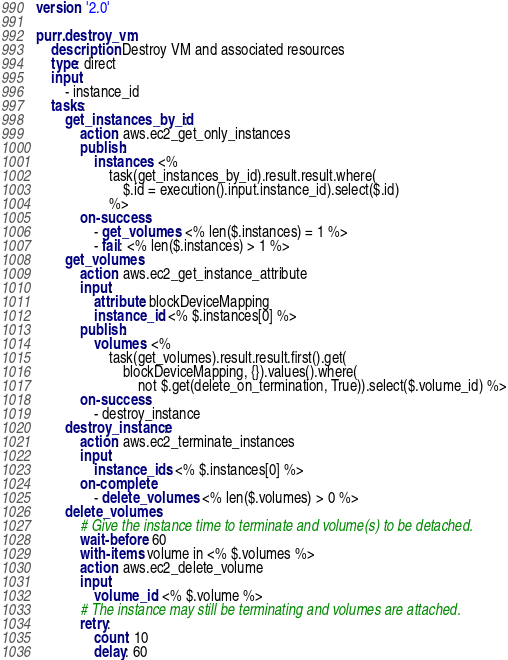Convert code to text. <code><loc_0><loc_0><loc_500><loc_500><_YAML_>version: '2.0'

purr.destroy_vm:
    description: Destroy VM and associated resources
    type: direct
    input:
        - instance_id
    tasks:
        get_instances_by_id:
            action: aws.ec2_get_only_instances
            publish:
                instances: <%
                    task(get_instances_by_id).result.result.where(
                        $.id = execution().input.instance_id).select($.id)
                    %>
            on-success:
                - get_volumes: <% len($.instances) = 1 %>
                - fail: <% len($.instances) > 1 %>
        get_volumes:
            action: aws.ec2_get_instance_attribute
            input:
                attribute: blockDeviceMapping
                instance_id: <% $.instances[0] %>
            publish:
                volumes: <%
                    task(get_volumes).result.result.first().get(
                        blockDeviceMapping, {}).values().where(
                            not $.get(delete_on_termination, True)).select($.volume_id) %>
            on-success:
                - destroy_instance
        destroy_instance:
            action: aws.ec2_terminate_instances
            input:
                instance_ids: <% $.instances[0] %>
            on-complete:
                - delete_volumes: <% len($.volumes) > 0 %>
        delete_volumes:
            # Give the instance time to terminate and volume(s) to be detached.
            wait-before: 60
            with-items: volume in <% $.volumes %>
            action: aws.ec2_delete_volume
            input:
                volume_id: <% $.volume %>
            # The instance may still be terminating and volumes are attached.
            retry:
                count: 10
                delay: 60
</code> 